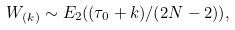<formula> <loc_0><loc_0><loc_500><loc_500>W _ { ( k ) } \sim E _ { 2 } ( ( \tau _ { 0 } + k ) / ( 2 N - 2 ) ) ,</formula> 